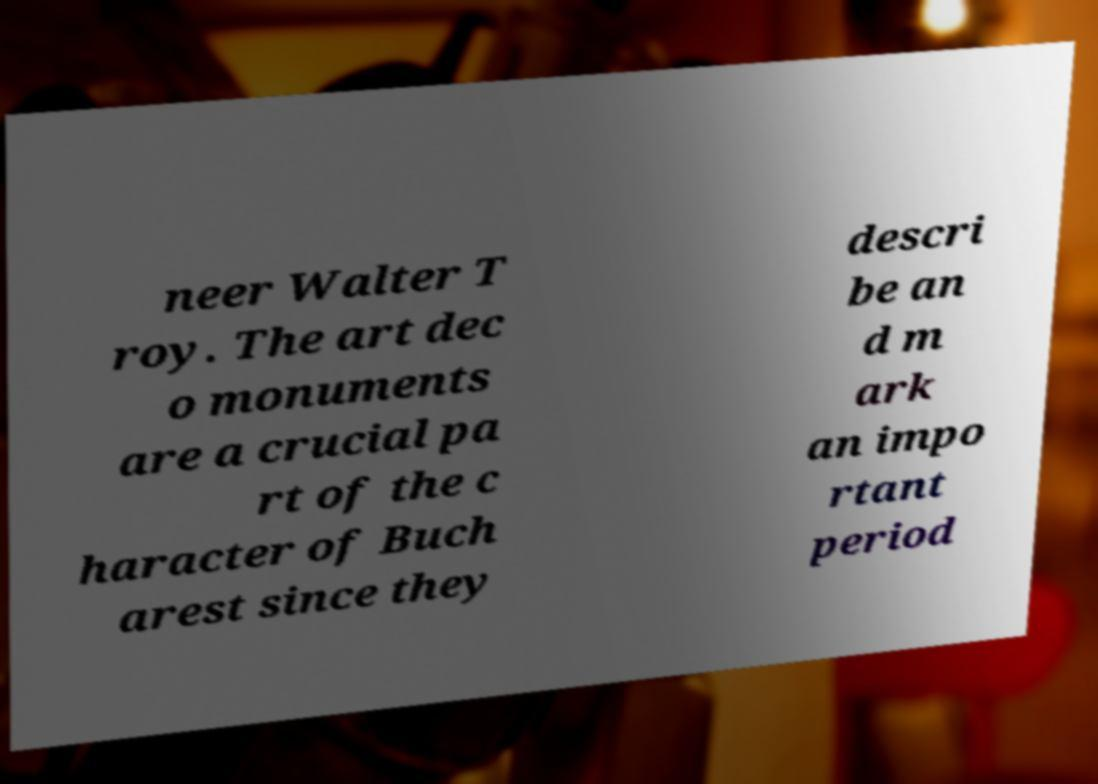Please read and relay the text visible in this image. What does it say? neer Walter T roy. The art dec o monuments are a crucial pa rt of the c haracter of Buch arest since they descri be an d m ark an impo rtant period 